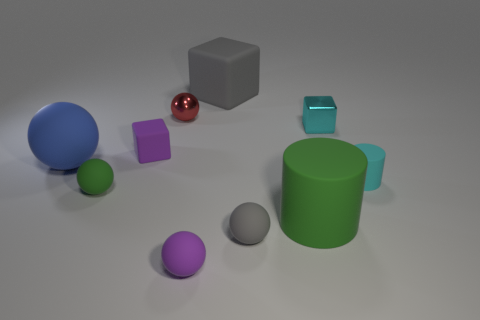How many tiny matte cylinders have the same color as the small metallic cube?
Make the answer very short. 1. How many things are big green objects or tiny spheres that are behind the tiny cyan shiny thing?
Your response must be concise. 2. Does the rubber cylinder behind the small green sphere have the same size as the rubber cube that is right of the purple block?
Your response must be concise. No. Is there a large blue thing that has the same material as the large gray object?
Give a very brief answer. Yes. The large green matte object is what shape?
Provide a succinct answer. Cylinder. There is a tiny purple object behind the tiny cyan object in front of the large blue object; what is its shape?
Your answer should be compact. Cube. What number of other objects are there of the same shape as the small red thing?
Your response must be concise. 4. How big is the cube that is right of the gray thing on the left side of the small gray matte object?
Your answer should be very brief. Small. Is there a large rubber sphere?
Your answer should be compact. Yes. What number of tiny things are in front of the purple object that is behind the small cylinder?
Keep it short and to the point. 4. 